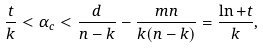Convert formula to latex. <formula><loc_0><loc_0><loc_500><loc_500>\frac { t } { k } < \alpha _ { c } < \frac { d } { n - k } - \frac { m n } { k ( n - k ) } = \frac { \ln + t } { k } ,</formula> 